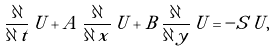<formula> <loc_0><loc_0><loc_500><loc_500>\frac { \partial } { \partial \, t } \, { U } + { A } \, \frac { \partial } { \partial \, x } \, { U } + { B } \, \frac { \partial } { \partial \, y } \, { U } = - { S } \, { U } ,</formula> 